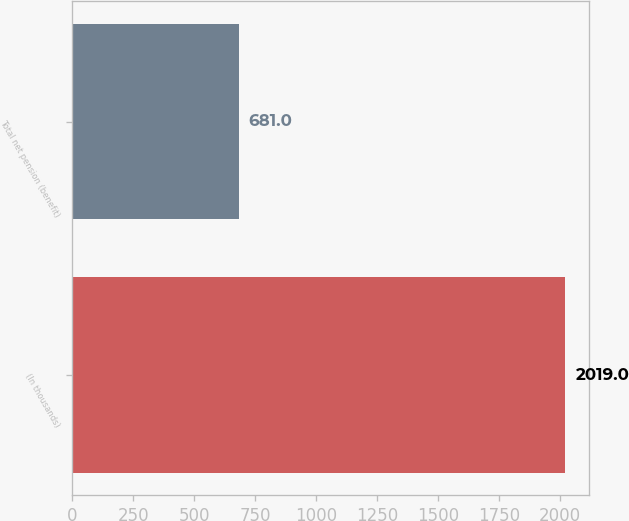Convert chart. <chart><loc_0><loc_0><loc_500><loc_500><bar_chart><fcel>(In thousands)<fcel>Total net pension (benefit)<nl><fcel>2019<fcel>681<nl></chart> 